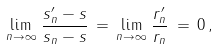<formula> <loc_0><loc_0><loc_500><loc_500>\lim _ { n \to \infty } \, \frac { s ^ { \prime } _ { n } - s } { s _ { n } - s } \, = \, \lim _ { n \to \infty } \, \frac { r ^ { \prime } _ { n } } { r _ { n } } \, = \, 0 \, ,</formula> 